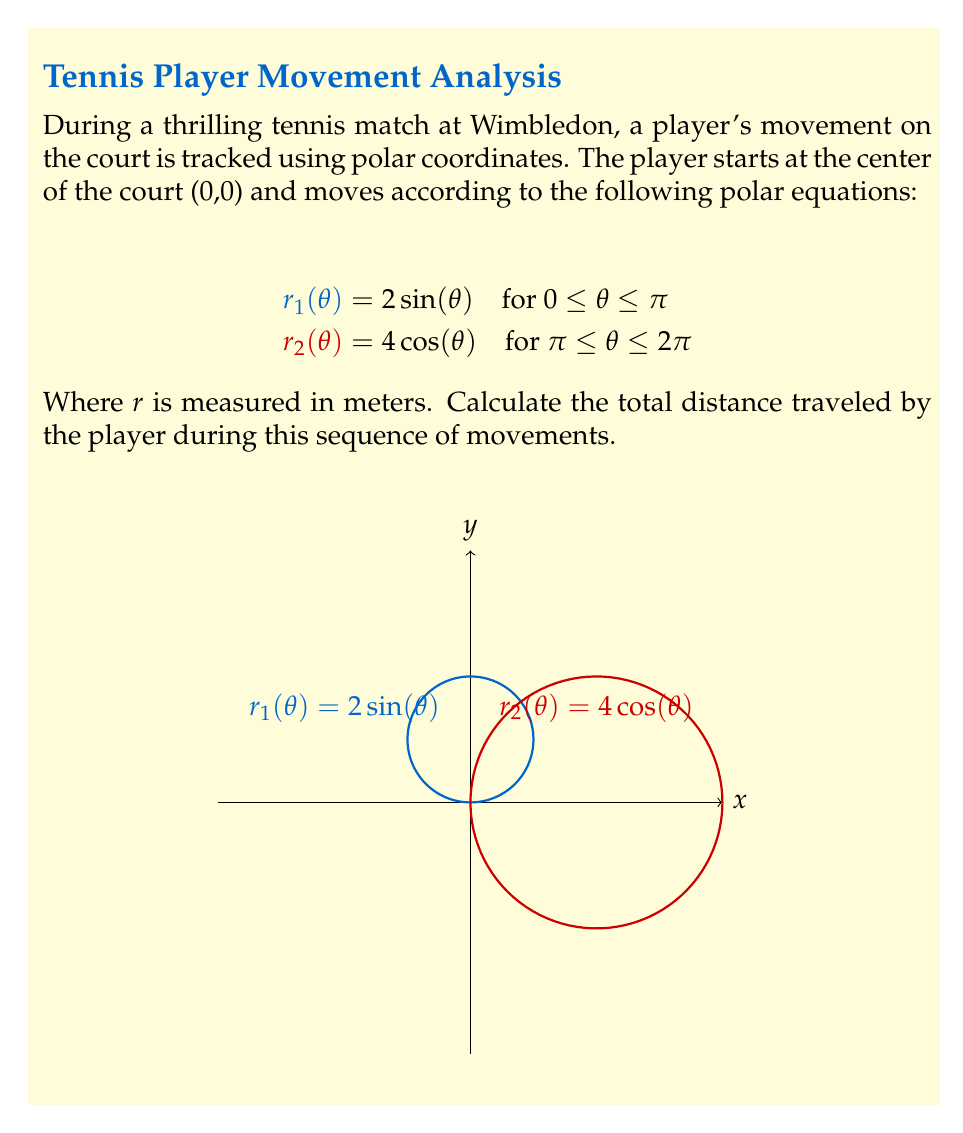Help me with this question. To find the total distance traveled, we need to calculate the arc length of both curves and sum them up. The formula for arc length in polar coordinates is:

$$L = \int_a^b \sqrt{r^2 + \left(\frac{dr}{dθ}\right)^2} dθ$$

For the first curve $r_1(θ) = 2 \sin(θ)$:
1) $\frac{dr_1}{dθ} = 2 \cos(θ)$
2) $L_1 = \int_0^π \sqrt{(2 \sin(θ))^2 + (2 \cos(θ))^2} dθ$
3) $L_1 = \int_0^π \sqrt{4 \sin^2(θ) + 4 \cos^2(θ)} dθ = \int_0^π \sqrt{4(\sin^2(θ) + \cos^2(θ))} dθ = \int_0^π 2 dθ = 2π$

For the second curve $r_2(θ) = 4 \cos(θ)$:
1) $\frac{dr_2}{dθ} = -4 \sin(θ)$
2) $L_2 = \int_π^{2π} \sqrt{(4 \cos(θ))^2 + (-4 \sin(θ))^2} dθ$
3) $L_2 = \int_π^{2π} \sqrt{16 \cos^2(θ) + 16 \sin^2(θ)} dθ = \int_π^{2π} \sqrt{16(\cos^2(θ) + \sin^2(θ))} dθ = \int_π^{2π} 4 dθ = 4π$

The total distance is the sum of both arc lengths:
$$L_{total} = L_1 + L_2 = 2π + 4π = 6π$$

Therefore, the total distance traveled by the player is $6π$ meters.
Answer: $6π$ meters 